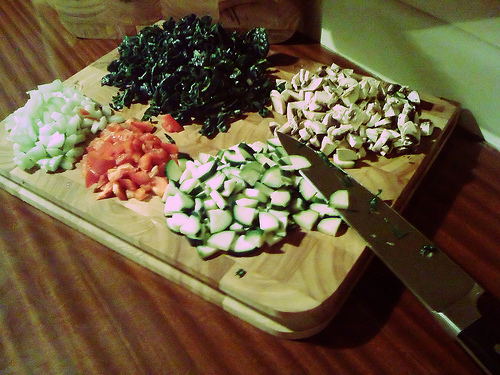<image>
Is there a spinach on the wood? Yes. Looking at the image, I can see the spinach is positioned on top of the wood, with the wood providing support. Is there a knife under the cutting board? No. The knife is not positioned under the cutting board. The vertical relationship between these objects is different. 